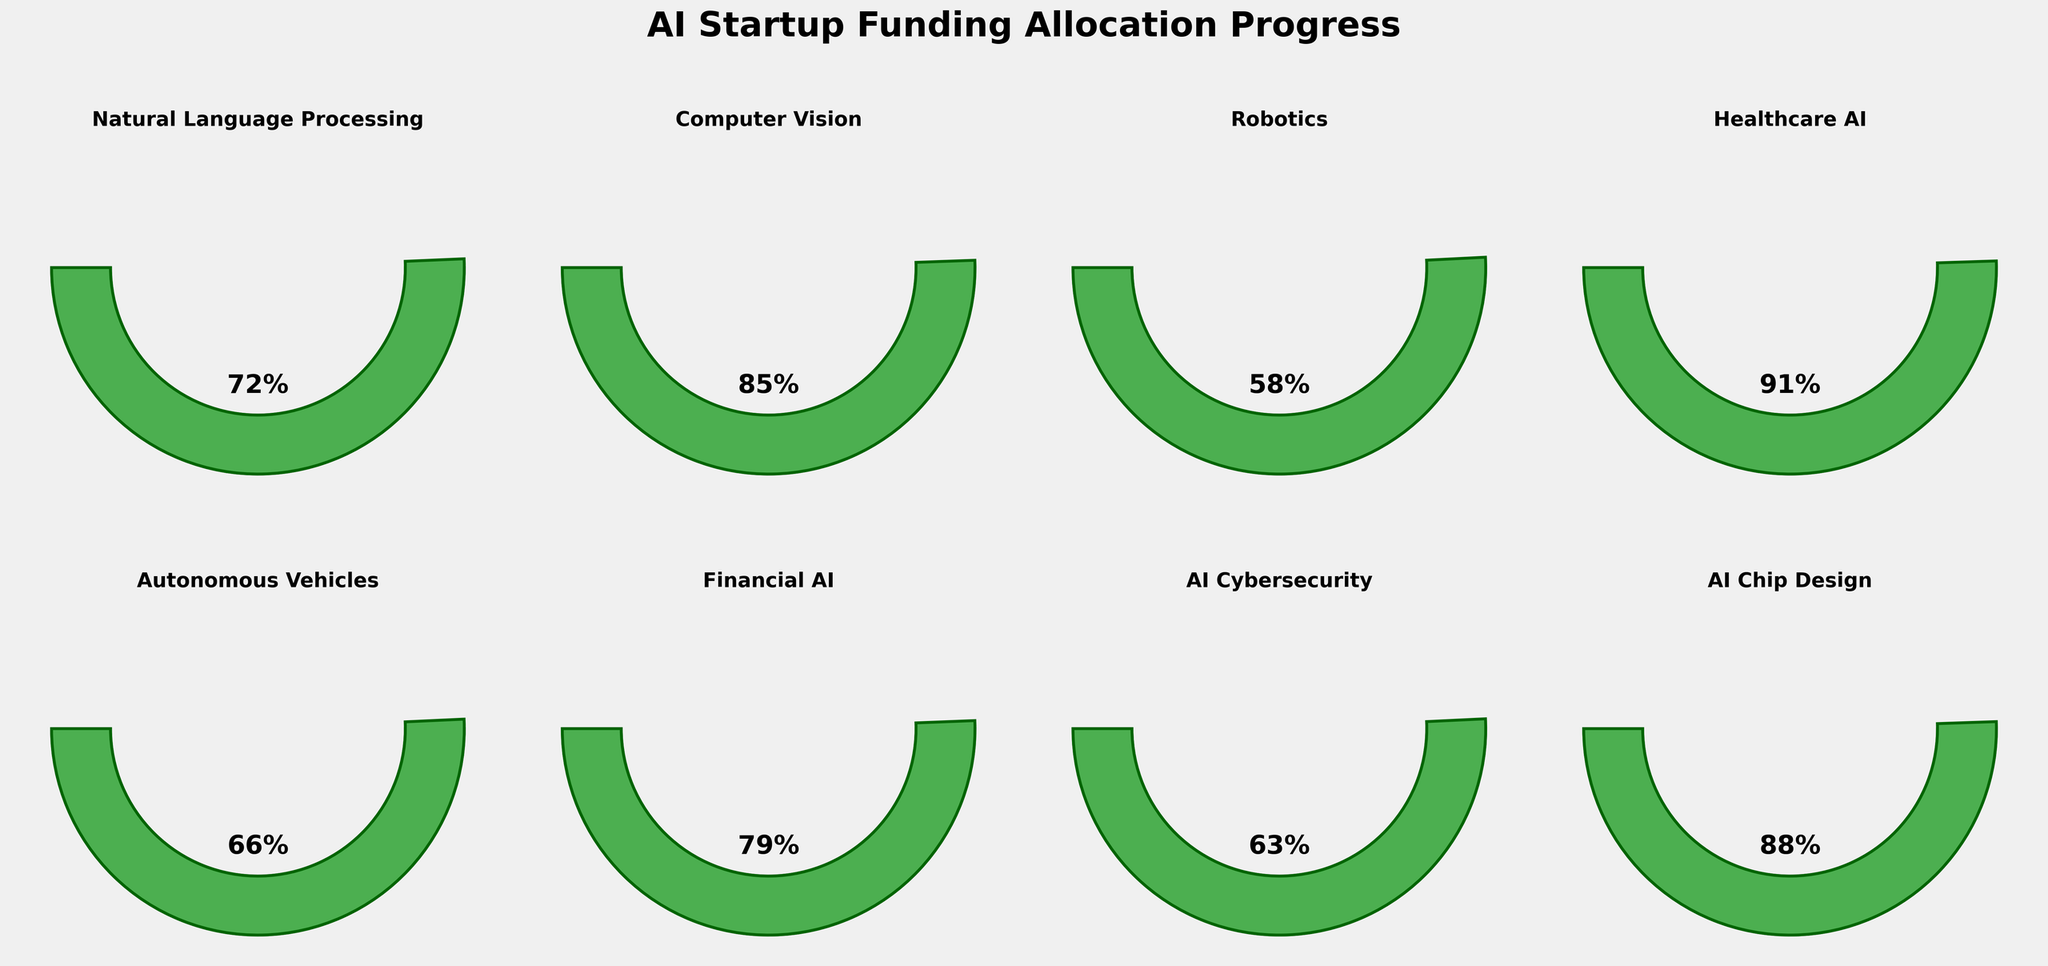What's the funding allocation progress for Natural Language Processing? The gauge for Natural Language Processing shows the needle at 72% of the funding target.
Answer: 72% Which AI sector has the highest funding allocation progress? The Healthcare AI gauge shows a needle at 91%, which is the highest among all sectors.
Answer: Healthcare AI What is the average funding allocation progress across all AI sectors? Sum the funding allocations: 72 + 85 + 58 + 91 + 66 + 79 + 63 + 88 = 602. Divide by the number of sectors: 602 / 8 = 75.25
Answer: 75.25% How many AI sectors have achieved more than 80% of their funding targets? The sectors with more than 80% funding are Computer Vision (85%), Healthcare AI (91%), and AI Chip Design (88%). This makes 3 sectors in total.
Answer: 3 Compare the funding allocation progress between AI Cybersecurity and Financial AI. Which one is higher? The gauge for Financial AI is at 79%, while AI Cybersecurity is at 63%. Financial AI is higher.
Answer: Financial AI What is the funding allocation difference between Computer Vision and Robotics? The funding for Computer Vision is 85%, and for Robotics, it is 58%. The difference is 85 - 58 = 27.
Answer: 27 Which sector has a funding allocation closest to 70%? The gauge for Natural Language Processing is at 72%, which is closest to 70%.
Answer: Natural Language Processing If we combine the funding allocations for Autonomous Vehicles and AI Cybersecurity, what is the total percentage? Autonomous Vehicles have 66%, and AI Cybersecurity has 63%. The total is 66 + 63 = 129%.
Answer: 129% What's the median funding allocation progress for all sectors? Arrange the funding percentages: 58, 63, 66, 72, 79, 85, 88, 91. The median is the average of the 4th and 5th values: (72 + 79) / 2 = 75.5%.
Answer: 75.5% Does any AI sector have a funding allocation below 60%? The gauge for Robotics shows a needle at 58%, which is below 60%.
Answer: Yes (Robotics) 